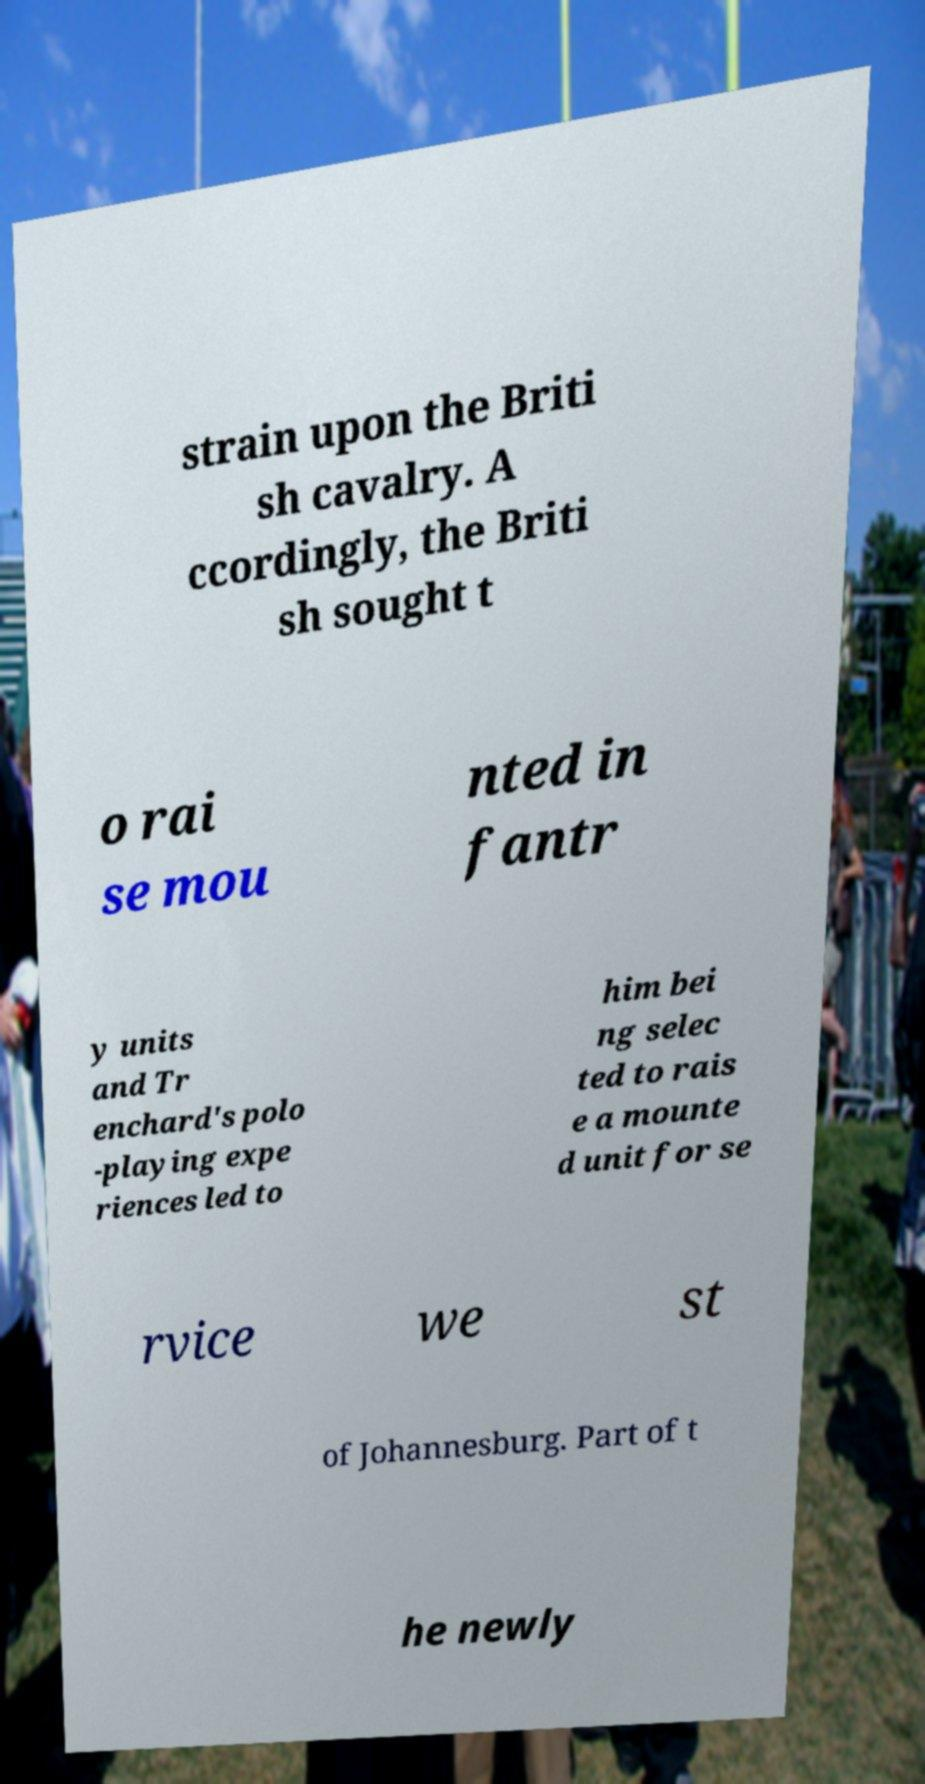Could you assist in decoding the text presented in this image and type it out clearly? strain upon the Briti sh cavalry. A ccordingly, the Briti sh sought t o rai se mou nted in fantr y units and Tr enchard's polo -playing expe riences led to him bei ng selec ted to rais e a mounte d unit for se rvice we st of Johannesburg. Part of t he newly 